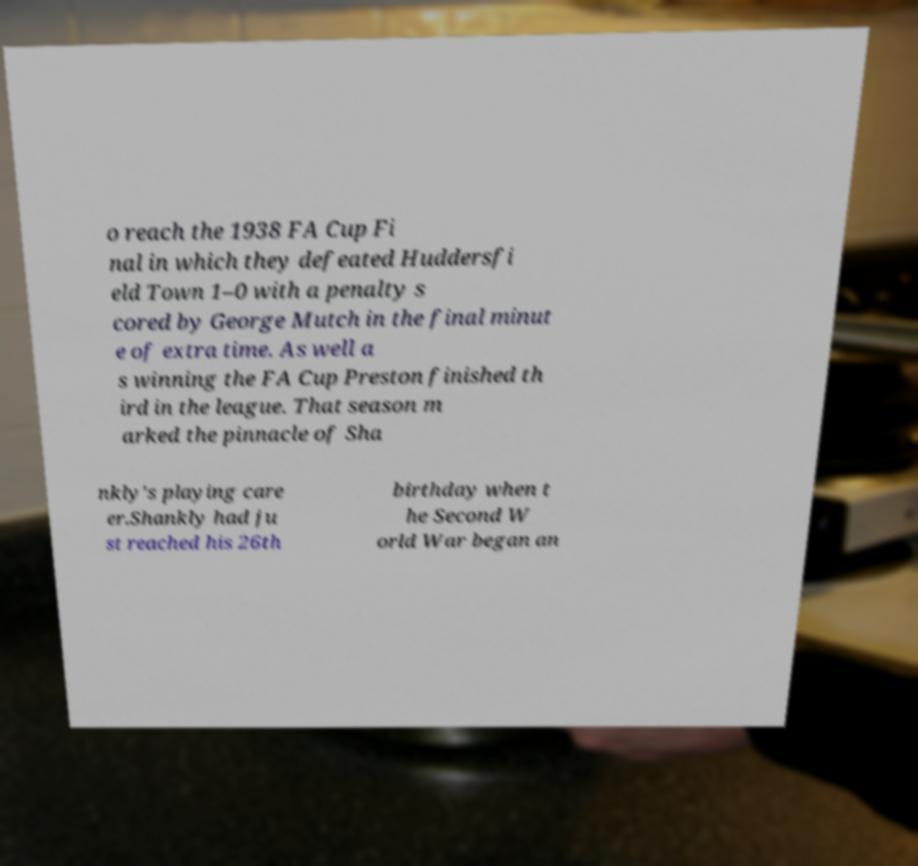For documentation purposes, I need the text within this image transcribed. Could you provide that? o reach the 1938 FA Cup Fi nal in which they defeated Huddersfi eld Town 1–0 with a penalty s cored by George Mutch in the final minut e of extra time. As well a s winning the FA Cup Preston finished th ird in the league. That season m arked the pinnacle of Sha nkly's playing care er.Shankly had ju st reached his 26th birthday when t he Second W orld War began an 